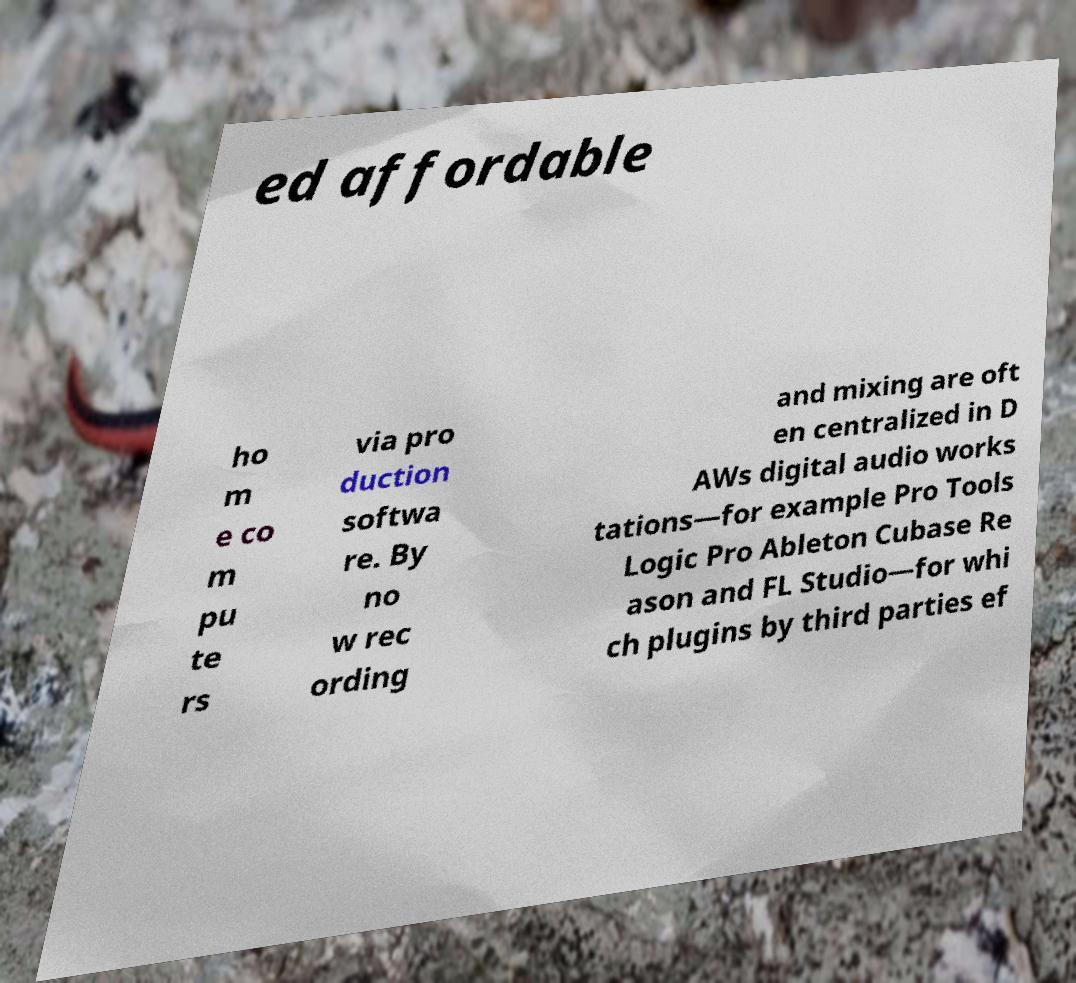Please read and relay the text visible in this image. What does it say? ed affordable ho m e co m pu te rs via pro duction softwa re. By no w rec ording and mixing are oft en centralized in D AWs digital audio works tations—for example Pro Tools Logic Pro Ableton Cubase Re ason and FL Studio—for whi ch plugins by third parties ef 